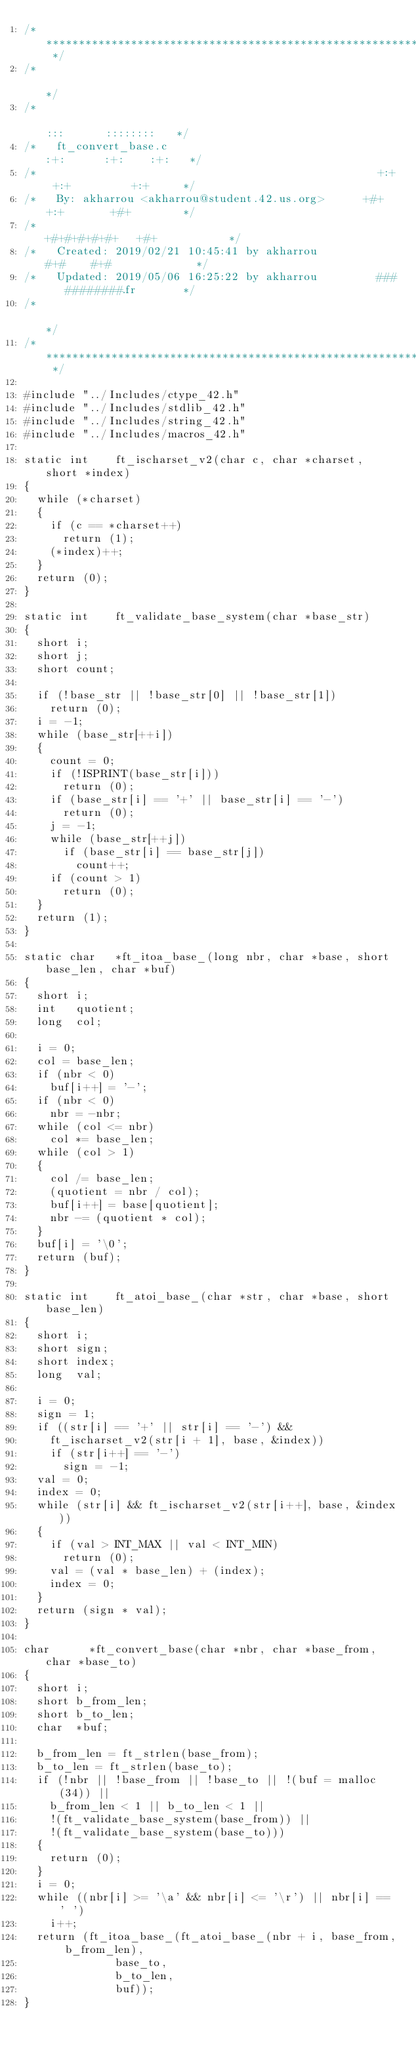Convert code to text. <code><loc_0><loc_0><loc_500><loc_500><_C_>/* ************************************************************************** */
/*                                                                            */
/*                                                        :::      ::::::::   */
/*   ft_convert_base.c                                  :+:      :+:    :+:   */
/*                                                    +:+ +:+         +:+     */
/*   By: akharrou <akharrou@student.42.us.org>      +#+  +:+       +#+        */
/*                                                +#+#+#+#+#+   +#+           */
/*   Created: 2019/02/21 10:45:41 by akharrou          #+#    #+#             */
/*   Updated: 2019/05/06 16:25:22 by akharrou         ###   ########.fr       */
/*                                                                            */
/* ************************************************************************** */

#include "../Includes/ctype_42.h"
#include "../Includes/stdlib_42.h"
#include "../Includes/string_42.h"
#include "../Includes/macros_42.h"

static int		ft_ischarset_v2(char c, char *charset, short *index)
{
	while (*charset)
	{
		if (c == *charset++)
			return (1);
		(*index)++;
	}
	return (0);
}

static int		ft_validate_base_system(char *base_str)
{
	short	i;
	short	j;
	short	count;

	if (!base_str || !base_str[0] || !base_str[1])
		return (0);
	i = -1;
	while (base_str[++i])
	{
		count = 0;
		if (!ISPRINT(base_str[i]))
			return (0);
		if (base_str[i] == '+' || base_str[i] == '-')
			return (0);
		j = -1;
		while (base_str[++j])
			if (base_str[i] == base_str[j])
				count++;
		if (count > 1)
			return (0);
	}
	return (1);
}

static char		*ft_itoa_base_(long nbr, char *base, short base_len, char *buf)
{
	short	i;
	int		quotient;
	long	col;

	i = 0;
	col = base_len;
	if (nbr < 0)
		buf[i++] = '-';
	if (nbr < 0)
		nbr = -nbr;
	while (col <= nbr)
		col *= base_len;
	while (col > 1)
	{
		col /= base_len;
		(quotient = nbr / col);
		buf[i++] = base[quotient];
		nbr -= (quotient * col);
	}
	buf[i] = '\0';
	return (buf);
}

static int		ft_atoi_base_(char *str, char *base, short base_len)
{
	short	i;
	short	sign;
	short	index;
	long	val;

	i = 0;
	sign = 1;
	if ((str[i] == '+' || str[i] == '-') &&
		ft_ischarset_v2(str[i + 1], base, &index))
		if (str[i++] == '-')
			sign = -1;
	val = 0;
	index = 0;
	while (str[i] && ft_ischarset_v2(str[i++], base, &index))
	{
		if (val > INT_MAX || val < INT_MIN)
			return (0);
		val = (val * base_len) + (index);
		index = 0;
	}
	return (sign * val);
}

char			*ft_convert_base(char *nbr, char *base_from, char *base_to)
{
	short	i;
	short	b_from_len;
	short	b_to_len;
	char	*buf;

	b_from_len = ft_strlen(base_from);
	b_to_len = ft_strlen(base_to);
	if (!nbr || !base_from || !base_to || !(buf = malloc(34)) ||
		b_from_len < 1 || b_to_len < 1 ||
		!(ft_validate_base_system(base_from)) ||
		!(ft_validate_base_system(base_to)))
	{
		return (0);
	}
	i = 0;
	while ((nbr[i] >= '\a' && nbr[i] <= '\r') || nbr[i] == ' ')
		i++;
	return (ft_itoa_base_(ft_atoi_base_(nbr + i, base_from, b_from_len),
							base_to,
							b_to_len,
							buf));
}
</code> 